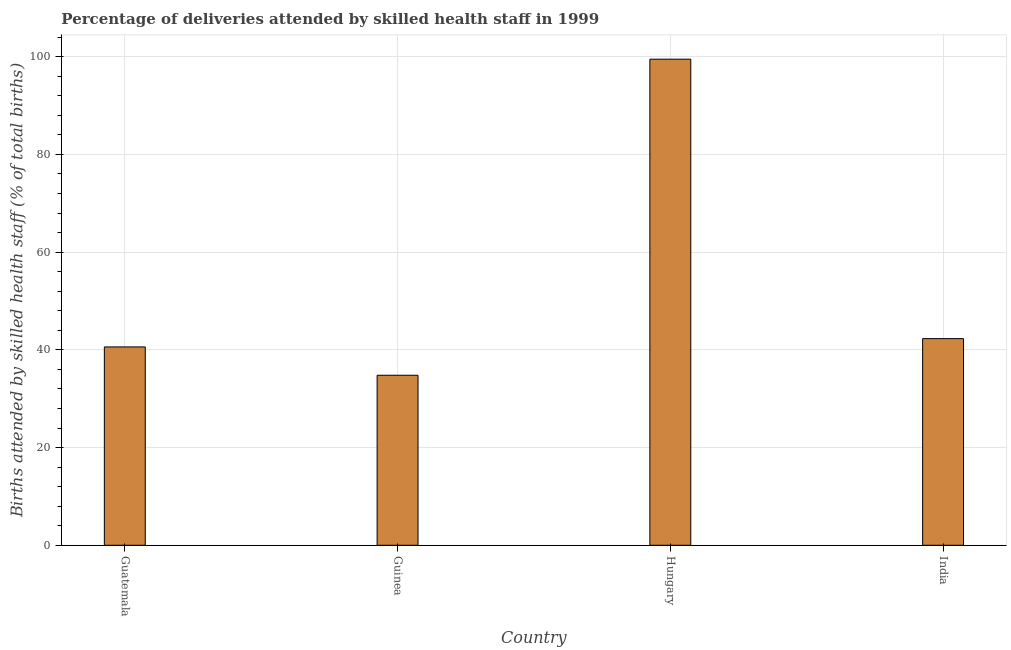What is the title of the graph?
Offer a very short reply. Percentage of deliveries attended by skilled health staff in 1999. What is the label or title of the X-axis?
Your answer should be compact. Country. What is the label or title of the Y-axis?
Provide a succinct answer. Births attended by skilled health staff (% of total births). What is the number of births attended by skilled health staff in India?
Provide a short and direct response. 42.3. Across all countries, what is the maximum number of births attended by skilled health staff?
Offer a very short reply. 99.5. Across all countries, what is the minimum number of births attended by skilled health staff?
Your response must be concise. 34.8. In which country was the number of births attended by skilled health staff maximum?
Offer a terse response. Hungary. In which country was the number of births attended by skilled health staff minimum?
Your answer should be very brief. Guinea. What is the sum of the number of births attended by skilled health staff?
Make the answer very short. 217.2. What is the difference between the number of births attended by skilled health staff in Guatemala and Hungary?
Make the answer very short. -58.9. What is the average number of births attended by skilled health staff per country?
Give a very brief answer. 54.3. What is the median number of births attended by skilled health staff?
Provide a succinct answer. 41.45. In how many countries, is the number of births attended by skilled health staff greater than 64 %?
Your response must be concise. 1. What is the ratio of the number of births attended by skilled health staff in Guatemala to that in Guinea?
Ensure brevity in your answer.  1.17. Is the number of births attended by skilled health staff in Guinea less than that in India?
Provide a succinct answer. Yes. Is the difference between the number of births attended by skilled health staff in Guatemala and Hungary greater than the difference between any two countries?
Make the answer very short. No. What is the difference between the highest and the second highest number of births attended by skilled health staff?
Make the answer very short. 57.2. Is the sum of the number of births attended by skilled health staff in Guatemala and Hungary greater than the maximum number of births attended by skilled health staff across all countries?
Offer a terse response. Yes. What is the difference between the highest and the lowest number of births attended by skilled health staff?
Your answer should be very brief. 64.7. How many bars are there?
Offer a very short reply. 4. What is the Births attended by skilled health staff (% of total births) in Guatemala?
Ensure brevity in your answer.  40.6. What is the Births attended by skilled health staff (% of total births) in Guinea?
Your answer should be compact. 34.8. What is the Births attended by skilled health staff (% of total births) in Hungary?
Make the answer very short. 99.5. What is the Births attended by skilled health staff (% of total births) in India?
Your response must be concise. 42.3. What is the difference between the Births attended by skilled health staff (% of total births) in Guatemala and Guinea?
Keep it short and to the point. 5.8. What is the difference between the Births attended by skilled health staff (% of total births) in Guatemala and Hungary?
Provide a succinct answer. -58.9. What is the difference between the Births attended by skilled health staff (% of total births) in Guinea and Hungary?
Provide a short and direct response. -64.7. What is the difference between the Births attended by skilled health staff (% of total births) in Hungary and India?
Provide a succinct answer. 57.2. What is the ratio of the Births attended by skilled health staff (% of total births) in Guatemala to that in Guinea?
Your answer should be compact. 1.17. What is the ratio of the Births attended by skilled health staff (% of total births) in Guatemala to that in Hungary?
Your answer should be compact. 0.41. What is the ratio of the Births attended by skilled health staff (% of total births) in Guatemala to that in India?
Make the answer very short. 0.96. What is the ratio of the Births attended by skilled health staff (% of total births) in Guinea to that in Hungary?
Your answer should be compact. 0.35. What is the ratio of the Births attended by skilled health staff (% of total births) in Guinea to that in India?
Provide a short and direct response. 0.82. What is the ratio of the Births attended by skilled health staff (% of total births) in Hungary to that in India?
Your answer should be compact. 2.35. 